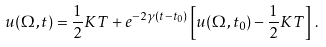Convert formula to latex. <formula><loc_0><loc_0><loc_500><loc_500>u ( \Omega , t ) = \frac { 1 } { 2 } K T + e ^ { - 2 \gamma ( t - t _ { 0 } ) } \left [ u ( \Omega , t _ { 0 } ) - \frac { 1 } { 2 } K T \right ] \, .</formula> 